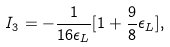Convert formula to latex. <formula><loc_0><loc_0><loc_500><loc_500>I _ { 3 } = - \frac { 1 } { 1 6 \epsilon _ { L } } [ 1 + \frac { 9 } { 8 } \epsilon _ { L } ] ,</formula> 